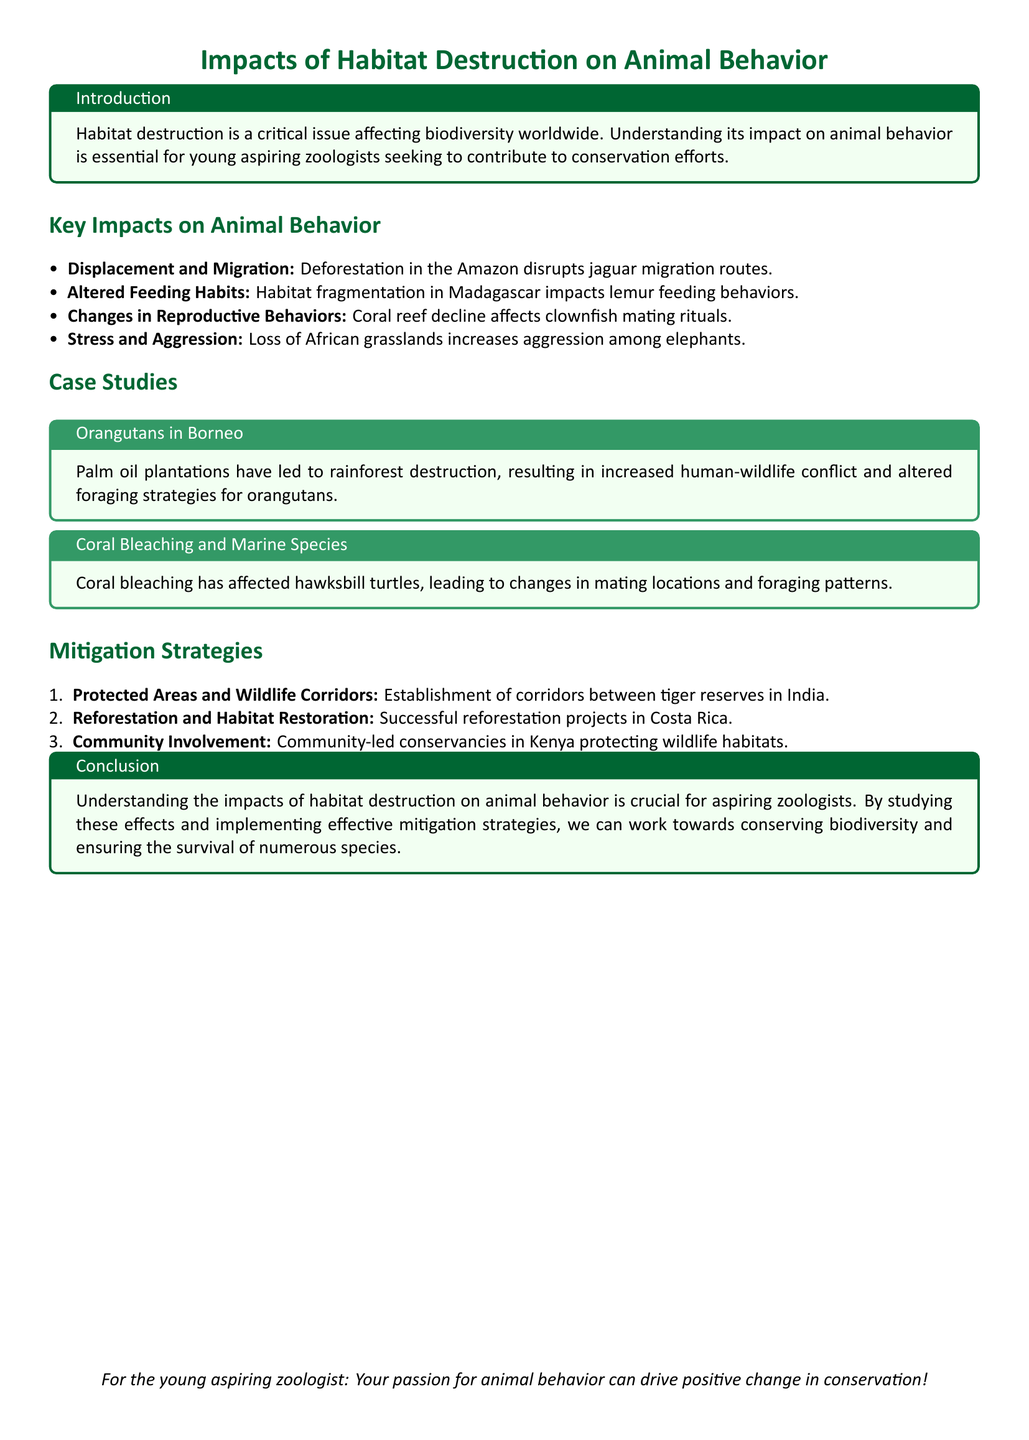What is the main topic of the document? The main topic is the impact of habitat destruction on animal behavior.
Answer: Impacts of Habitat Destruction on Animal Behavior What animal behavior is altered due to deforestation in the Amazon? The document states that deforestation disrupts jaguar migration routes.
Answer: Jaguar migration routes Which species' mating rituals are affected by coral reef decline? The document mentions that clownfish mating rituals are impacted.
Answer: Clownfish What type of agriculture has led to rainforest destruction in Borneo? The document refers to palm oil plantations causing this issue.
Answer: Palm oil plantations Name one successful reforestation project location mentioned. The document lists Costa Rica as a location of successful reforestation projects.
Answer: Costa Rica What is a strategy mentioned for protecting wildlife habitats in India? The document indicates the establishment of corridors between tiger reserves.
Answer: Wildlife corridors How does habitat fragmentation in Madagascar affect lemurs? The document states that it impacts lemur feeding behaviors.
Answer: Feeding behaviors What is one effect of habitat destruction on elephants? The document notes that loss of African grasslands increases aggression among elephants.
Answer: Increased aggression 